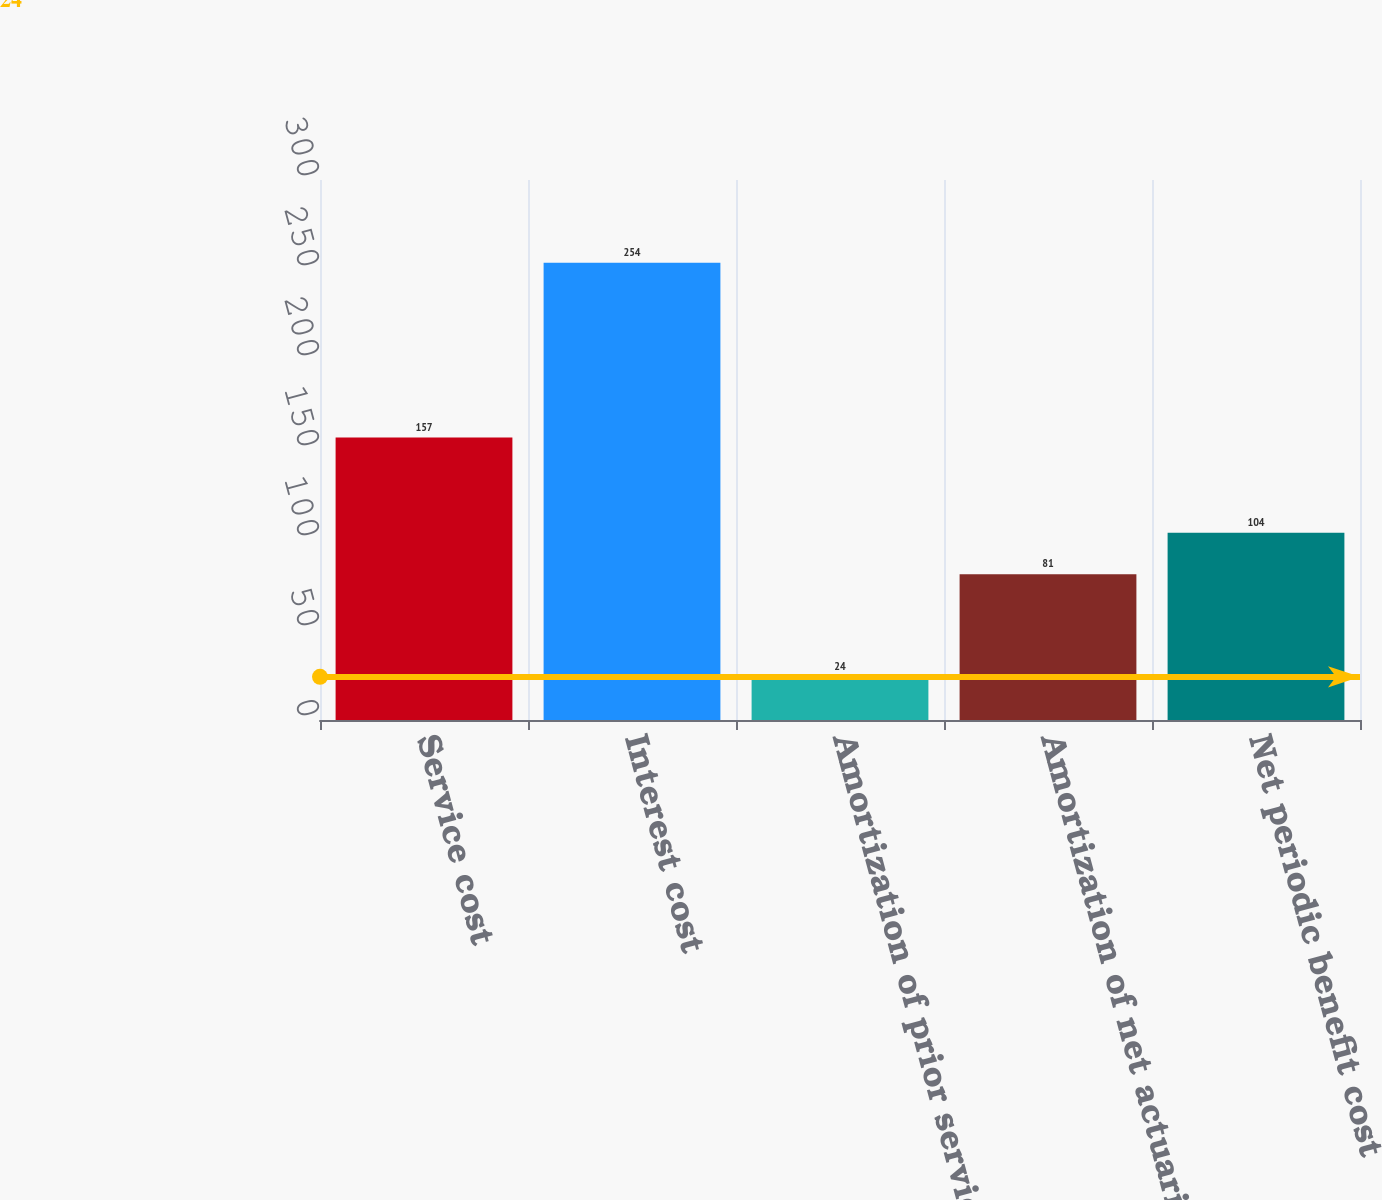Convert chart to OTSL. <chart><loc_0><loc_0><loc_500><loc_500><bar_chart><fcel>Service cost<fcel>Interest cost<fcel>Amortization of prior service<fcel>Amortization of net actuarial<fcel>Net periodic benefit cost<nl><fcel>157<fcel>254<fcel>24<fcel>81<fcel>104<nl></chart> 